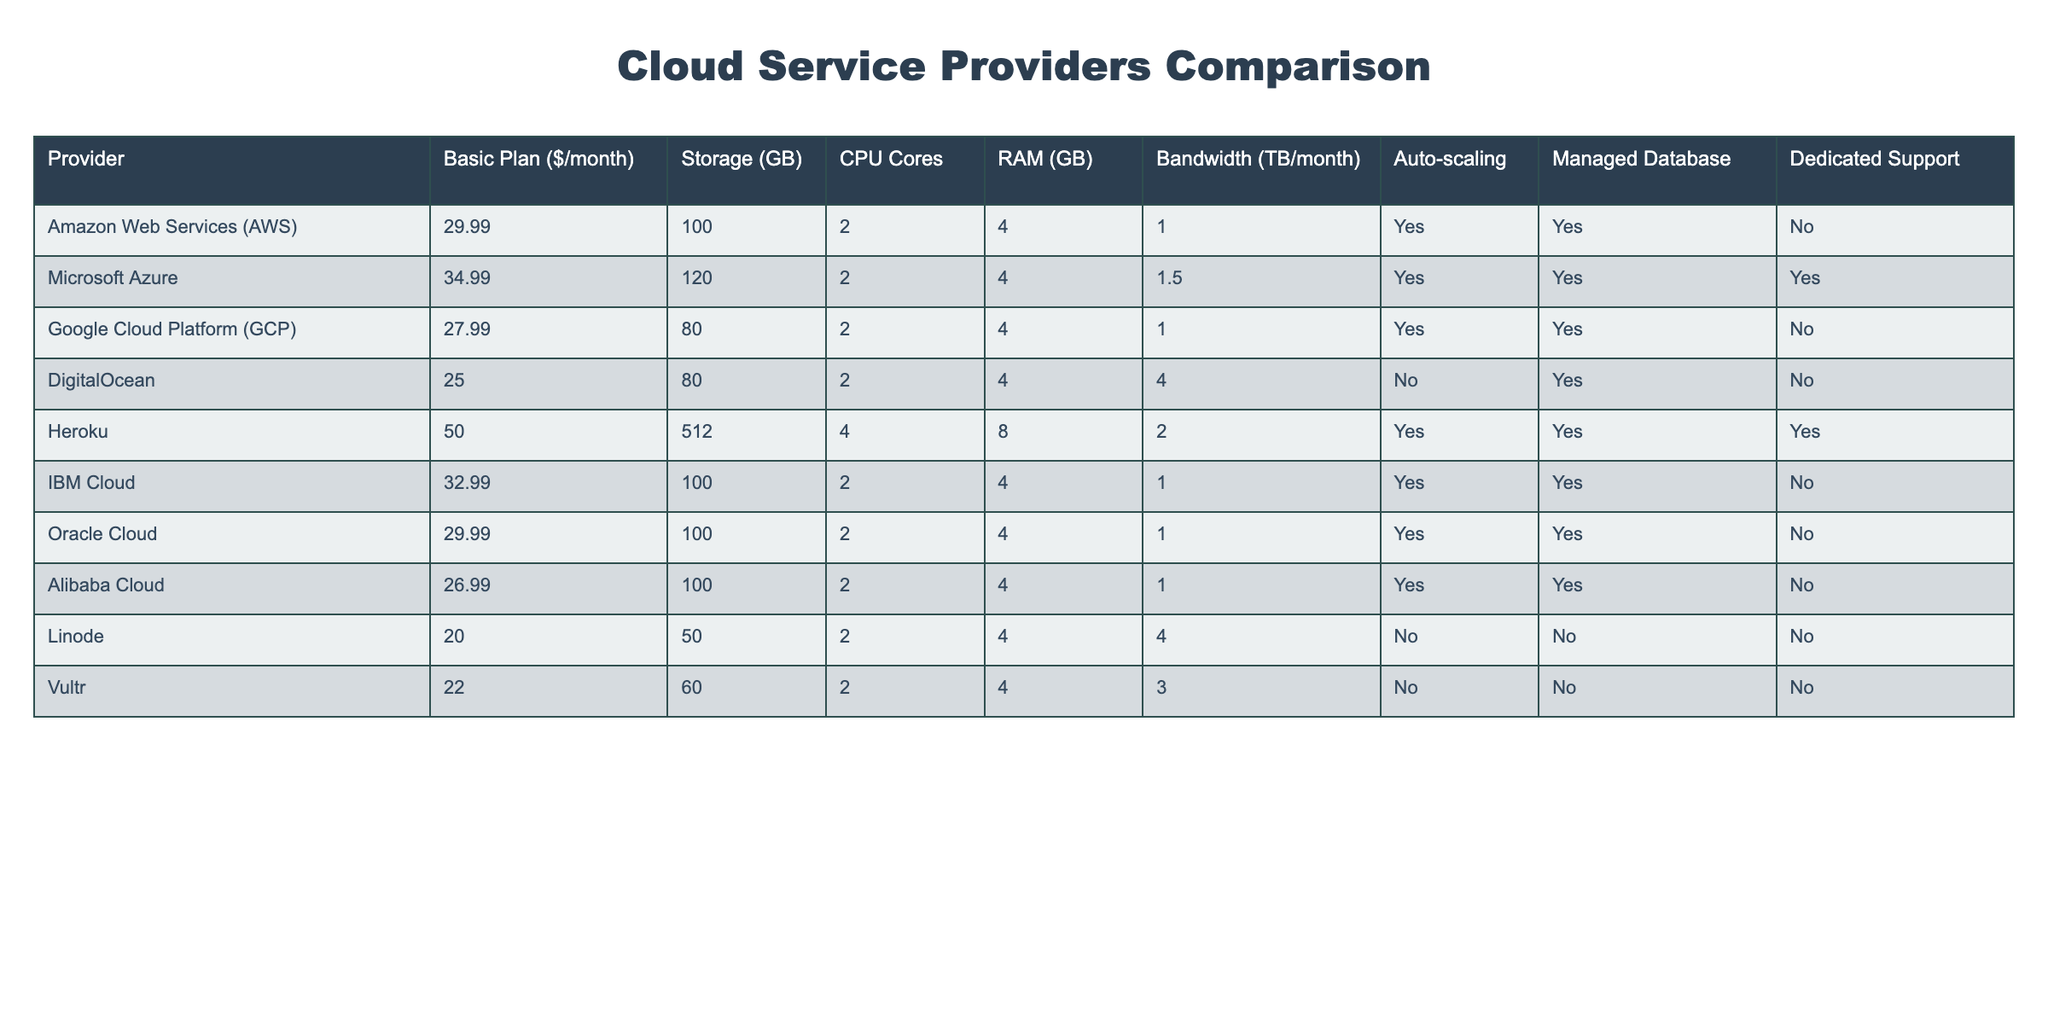What is the lowest basic plan price among the providers? Looking at the "Basic Plan ($/month)" column, the lowest price listed is $20, provided by Linode.
Answer: 20 Which provider offers the most storage space for the basic plan? Upon checking the "Storage (GB)" column, Heroku provides the most storage, with 512 GB.
Answer: 512 What is the average RAM offered by the listed providers? The RAM values are: 4, 4, 4, 4, 8, 4, 4, 4, 4 (9 values). Summing these gives 4 * 8 + 8 = 40, and dividing by 9 results in approximately 4.44.
Answer: 4.44 Does Google Cloud Platform offer dedicated support? In the "Dedicated Support" column, Google Cloud Platform is listed as "No".
Answer: No How many providers offer automatic scaling? From the data in the "Auto-scaling" column, AWS, Microsoft Azure, GCP, IBM Cloud, and Oracle Cloud all offer this feature (5 providers in total).
Answer: 5 Which provider has the highest monthly fee and how much is it? Heroku has the highest fee of $50, the maximum in the "Basic Plan ($/month)" column.
Answer: 50 Is there a provider that offers both a managed database and dedicated support? From the table, the providers that offer both features are Microsoft Azure and Heroku, confirming that such providers exist.
Answer: Yes What is the bandwidth offered by DigitalOcean as compared to Linode? DigitalOcean provides 4 TB/month, while Linode offers 4 TB/month as well. They have the same bandwidth offering.
Answer: Same (4 TB/month) How many CPU cores does Alibaba Cloud provide? In the "CPU Cores" column, Alibaba Cloud is listed with 2 CPU cores.
Answer: 2 